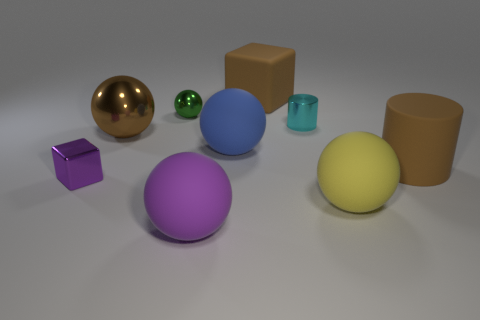Can you describe the textures of the objects? While the image is not high-resolution, the objects seem to have a mostly smooth and shiny surface, suggesting metallic or plastic materials. Are there any objects that reflect light differently? Yes, the golden sphere reflects light in a way that suggests it's more reflective or has a glossier finish compared to the others. 